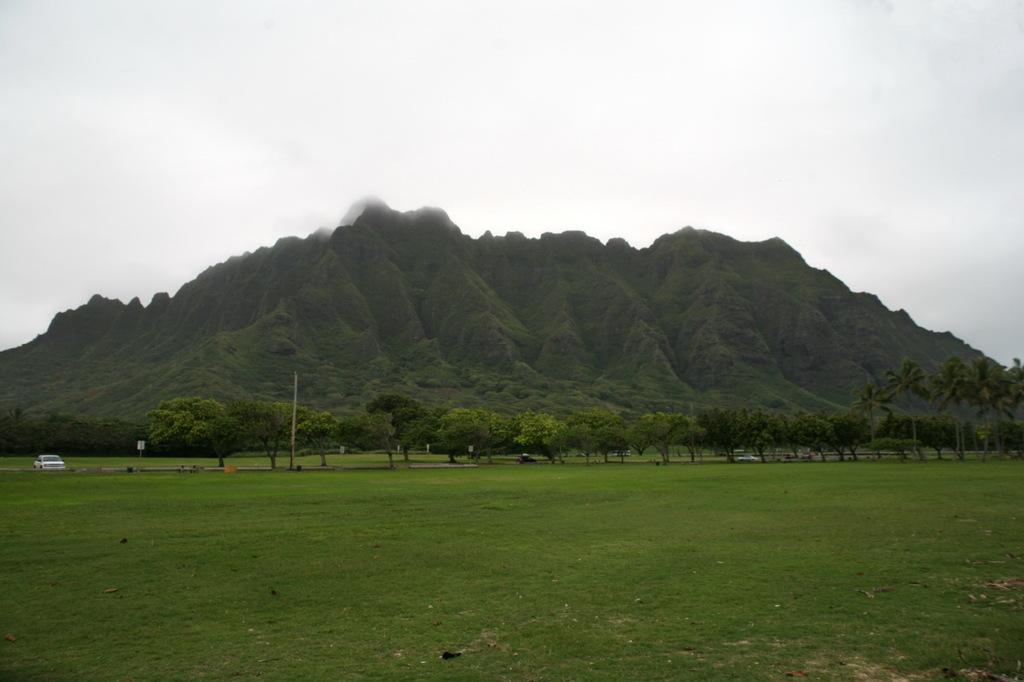What type of landscape is depicted in the image? There is a grassland in the image. What other natural elements can be seen in the image? There are trees and hills in the image. What is happening on the road in the image? Vehicles are moving on the road in the image. What type of plants are present in the image? There are palos in the image. What is visible in the background of the image? The sky is visible in the background of the image. How many pairs of shoes can be seen on the grass in the image? There are no shoes visible in the image; it depicts a grassland, trees, hills, vehicles, palos, and the sky. What type of sponge is being used to clean the trees in the image? There is no sponge present in the image, and the trees are not being cleaned. 